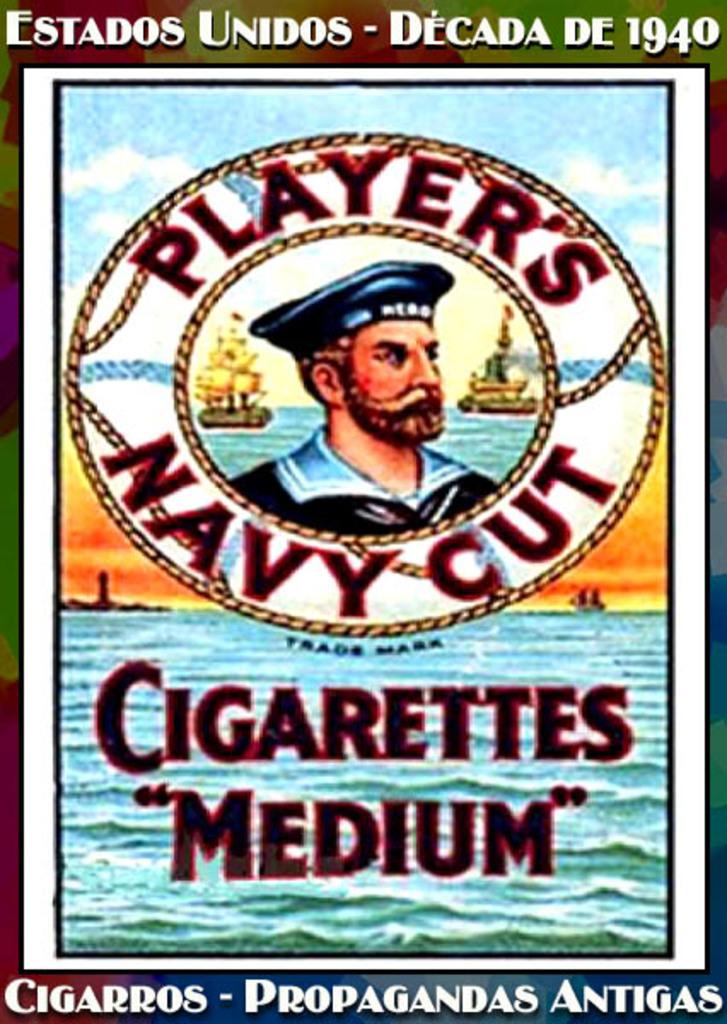What size is this?
Make the answer very short. Medium. What kind of cut is this?
Provide a succinct answer. Navy. 